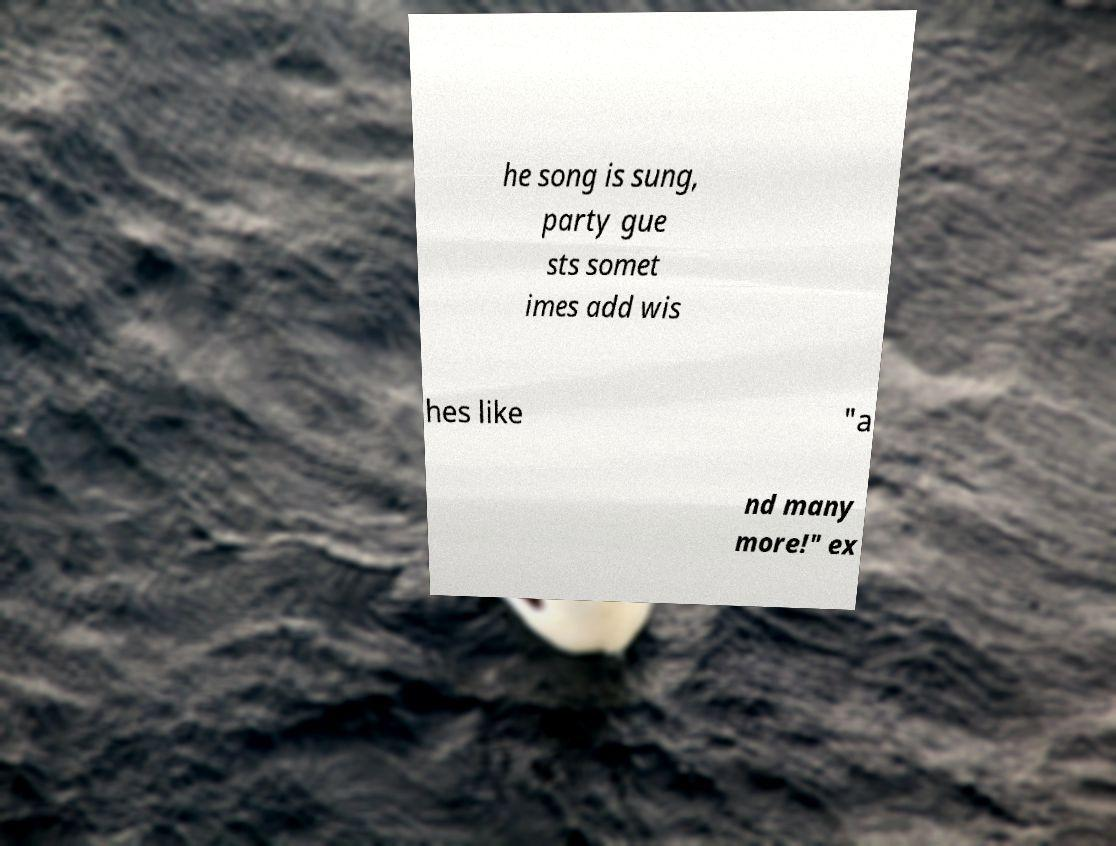There's text embedded in this image that I need extracted. Can you transcribe it verbatim? he song is sung, party gue sts somet imes add wis hes like "a nd many more!" ex 